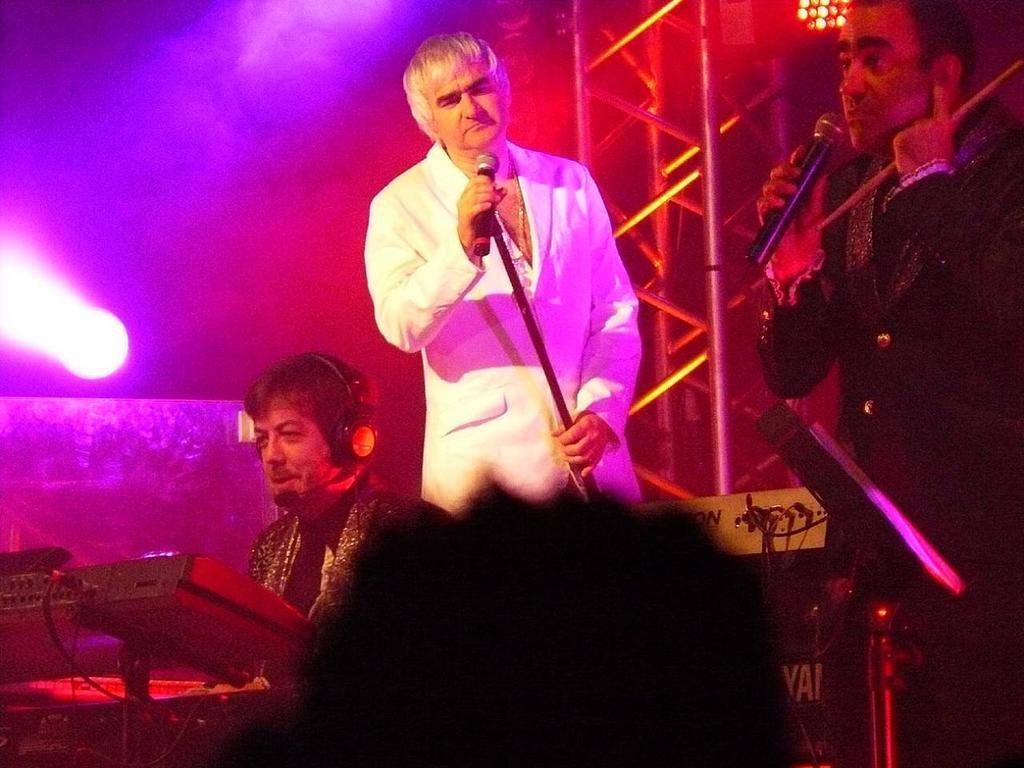What is the man in the middle of the image doing? The man in the middle of the image is standing and singing. What color coat is the man in the middle wearing? The man in the middle is wearing a white color coat. Can you describe the man on the right side of the image? The man on the right side of the image is wearing a black color coat. What can be seen on the left side of the image? There is a light on the left side of the image. How many carts are visible in the image? There are no carts present in the image. What shape are the chickens in the image? There are no chickens present in the image. 